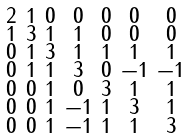Convert formula to latex. <formula><loc_0><loc_0><loc_500><loc_500>\begin{smallmatrix} 2 & 1 & 0 & 0 & 0 & 0 & 0 \\ 1 & 3 & 1 & 1 & 0 & 0 & 0 \\ 0 & 1 & 3 & 1 & 1 & 1 & 1 \\ 0 & 1 & 1 & 3 & 0 & - 1 & - 1 \\ 0 & 0 & 1 & 0 & 3 & 1 & 1 \\ 0 & 0 & 1 & - 1 & 1 & 3 & 1 \\ 0 & 0 & 1 & - 1 & 1 & 1 & 3 \end{smallmatrix}</formula> 